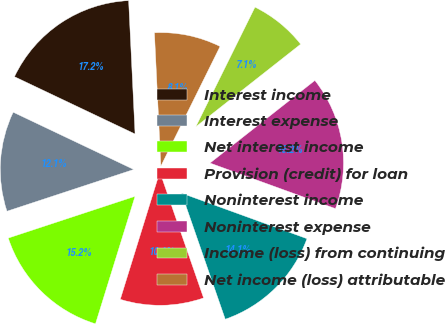Convert chart to OTSL. <chart><loc_0><loc_0><loc_500><loc_500><pie_chart><fcel>Interest income<fcel>Interest expense<fcel>Net interest income<fcel>Provision (credit) for loan<fcel>Noninterest income<fcel>Noninterest expense<fcel>Income (loss) from continuing<fcel>Net income (loss) attributable<nl><fcel>17.17%<fcel>12.12%<fcel>15.15%<fcel>10.1%<fcel>14.14%<fcel>16.16%<fcel>7.07%<fcel>8.08%<nl></chart> 